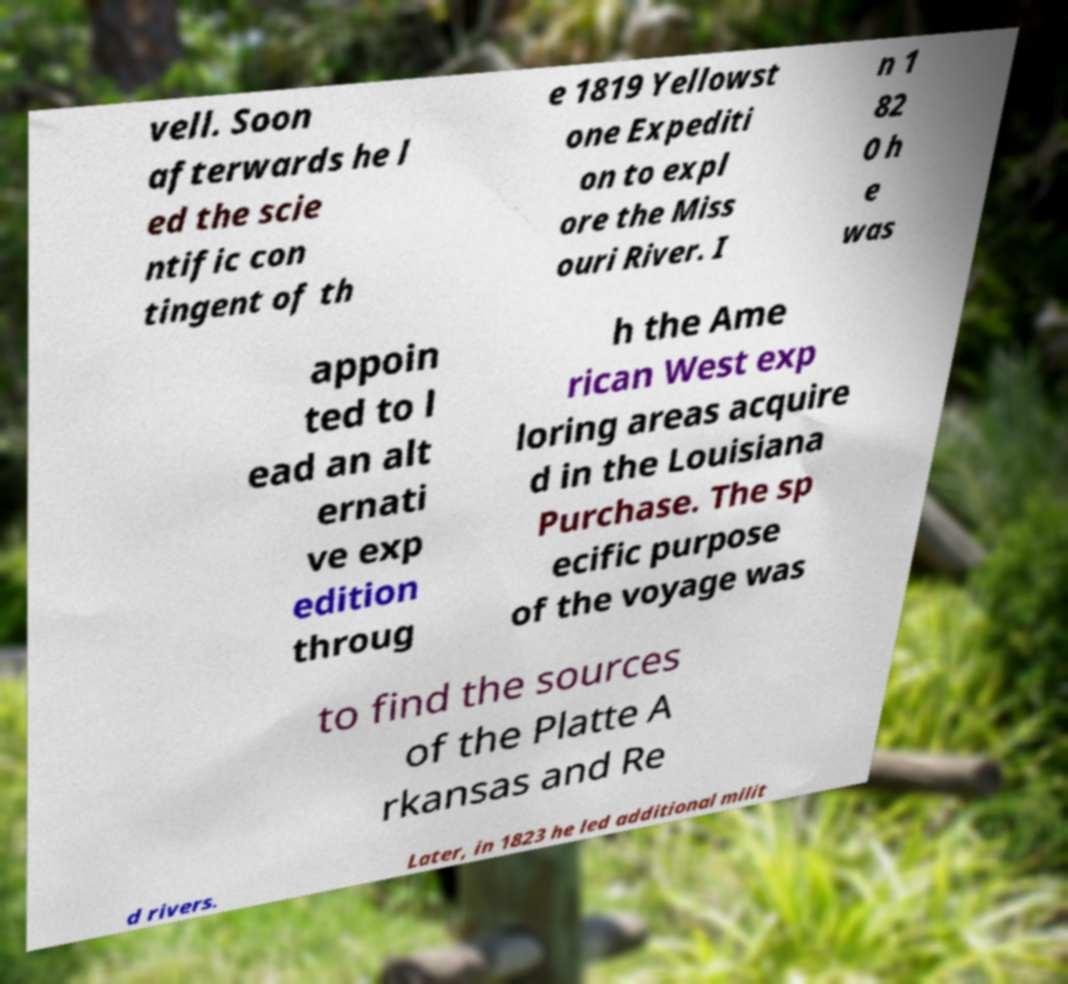For documentation purposes, I need the text within this image transcribed. Could you provide that? vell. Soon afterwards he l ed the scie ntific con tingent of th e 1819 Yellowst one Expediti on to expl ore the Miss ouri River. I n 1 82 0 h e was appoin ted to l ead an alt ernati ve exp edition throug h the Ame rican West exp loring areas acquire d in the Louisiana Purchase. The sp ecific purpose of the voyage was to find the sources of the Platte A rkansas and Re d rivers. Later, in 1823 he led additional milit 